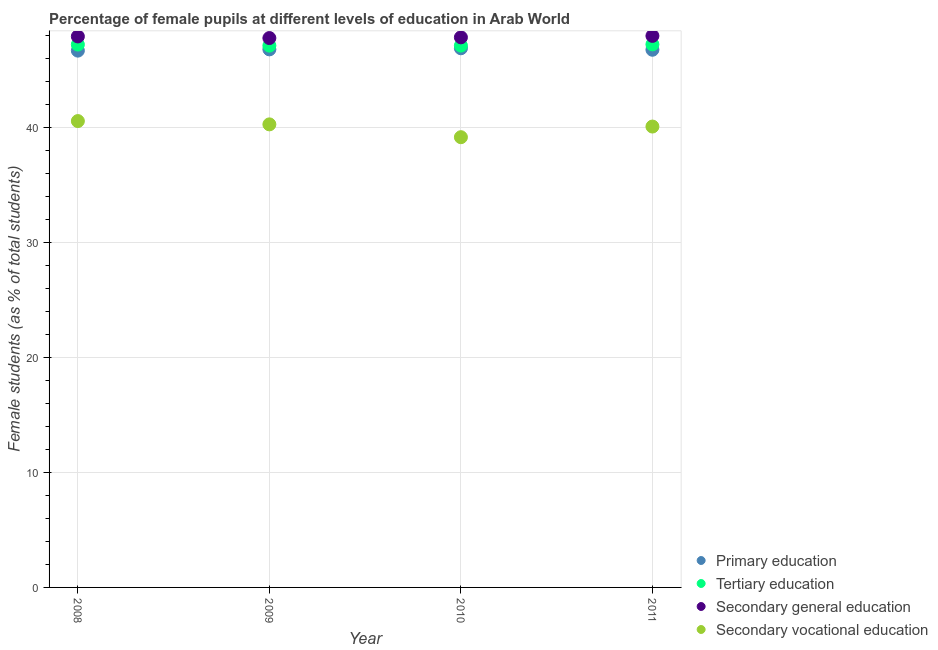What is the percentage of female students in primary education in 2008?
Offer a very short reply. 46.71. Across all years, what is the maximum percentage of female students in tertiary education?
Make the answer very short. 47.25. Across all years, what is the minimum percentage of female students in primary education?
Offer a very short reply. 46.71. What is the total percentage of female students in secondary vocational education in the graph?
Your answer should be compact. 160.15. What is the difference between the percentage of female students in secondary education in 2009 and that in 2010?
Ensure brevity in your answer.  -0.06. What is the difference between the percentage of female students in secondary education in 2011 and the percentage of female students in tertiary education in 2010?
Give a very brief answer. 0.84. What is the average percentage of female students in tertiary education per year?
Offer a very short reply. 47.19. In the year 2008, what is the difference between the percentage of female students in primary education and percentage of female students in secondary education?
Provide a short and direct response. -1.23. In how many years, is the percentage of female students in secondary education greater than 20 %?
Your answer should be compact. 4. What is the ratio of the percentage of female students in secondary education in 2009 to that in 2011?
Give a very brief answer. 1. Is the percentage of female students in primary education in 2009 less than that in 2010?
Provide a short and direct response. Yes. What is the difference between the highest and the second highest percentage of female students in primary education?
Give a very brief answer. 0.1. What is the difference between the highest and the lowest percentage of female students in primary education?
Give a very brief answer. 0.21. In how many years, is the percentage of female students in tertiary education greater than the average percentage of female students in tertiary education taken over all years?
Offer a terse response. 2. Is the sum of the percentage of female students in secondary education in 2010 and 2011 greater than the maximum percentage of female students in secondary vocational education across all years?
Your response must be concise. Yes. Is it the case that in every year, the sum of the percentage of female students in primary education and percentage of female students in tertiary education is greater than the percentage of female students in secondary education?
Provide a short and direct response. Yes. Does the percentage of female students in secondary education monotonically increase over the years?
Make the answer very short. No. Is the percentage of female students in tertiary education strictly greater than the percentage of female students in secondary vocational education over the years?
Make the answer very short. Yes. Is the percentage of female students in primary education strictly less than the percentage of female students in secondary vocational education over the years?
Ensure brevity in your answer.  No. How many dotlines are there?
Keep it short and to the point. 4. Are the values on the major ticks of Y-axis written in scientific E-notation?
Provide a succinct answer. No. Does the graph contain any zero values?
Ensure brevity in your answer.  No. How many legend labels are there?
Make the answer very short. 4. What is the title of the graph?
Provide a short and direct response. Percentage of female pupils at different levels of education in Arab World. What is the label or title of the X-axis?
Offer a very short reply. Year. What is the label or title of the Y-axis?
Ensure brevity in your answer.  Female students (as % of total students). What is the Female students (as % of total students) of Primary education in 2008?
Give a very brief answer. 46.71. What is the Female students (as % of total students) in Tertiary education in 2008?
Provide a short and direct response. 47.24. What is the Female students (as % of total students) of Secondary general education in 2008?
Ensure brevity in your answer.  47.94. What is the Female students (as % of total students) in Secondary vocational education in 2008?
Ensure brevity in your answer.  40.58. What is the Female students (as % of total students) of Primary education in 2009?
Offer a very short reply. 46.82. What is the Female students (as % of total students) in Tertiary education in 2009?
Offer a terse response. 47.14. What is the Female students (as % of total students) in Secondary general education in 2009?
Offer a terse response. 47.8. What is the Female students (as % of total students) in Secondary vocational education in 2009?
Your response must be concise. 40.29. What is the Female students (as % of total students) in Primary education in 2010?
Keep it short and to the point. 46.91. What is the Female students (as % of total students) of Tertiary education in 2010?
Provide a succinct answer. 47.15. What is the Female students (as % of total students) of Secondary general education in 2010?
Offer a terse response. 47.86. What is the Female students (as % of total students) of Secondary vocational education in 2010?
Keep it short and to the point. 39.18. What is the Female students (as % of total students) in Primary education in 2011?
Keep it short and to the point. 46.79. What is the Female students (as % of total students) of Tertiary education in 2011?
Your response must be concise. 47.25. What is the Female students (as % of total students) in Secondary general education in 2011?
Provide a short and direct response. 47.99. What is the Female students (as % of total students) in Secondary vocational education in 2011?
Give a very brief answer. 40.1. Across all years, what is the maximum Female students (as % of total students) of Primary education?
Make the answer very short. 46.91. Across all years, what is the maximum Female students (as % of total students) of Tertiary education?
Provide a succinct answer. 47.25. Across all years, what is the maximum Female students (as % of total students) in Secondary general education?
Provide a succinct answer. 47.99. Across all years, what is the maximum Female students (as % of total students) of Secondary vocational education?
Provide a short and direct response. 40.58. Across all years, what is the minimum Female students (as % of total students) of Primary education?
Make the answer very short. 46.71. Across all years, what is the minimum Female students (as % of total students) of Tertiary education?
Make the answer very short. 47.14. Across all years, what is the minimum Female students (as % of total students) in Secondary general education?
Your response must be concise. 47.8. Across all years, what is the minimum Female students (as % of total students) in Secondary vocational education?
Provide a succinct answer. 39.18. What is the total Female students (as % of total students) in Primary education in the graph?
Offer a terse response. 187.23. What is the total Female students (as % of total students) in Tertiary education in the graph?
Provide a succinct answer. 188.78. What is the total Female students (as % of total students) in Secondary general education in the graph?
Give a very brief answer. 191.6. What is the total Female students (as % of total students) in Secondary vocational education in the graph?
Provide a succinct answer. 160.15. What is the difference between the Female students (as % of total students) of Primary education in 2008 and that in 2009?
Ensure brevity in your answer.  -0.11. What is the difference between the Female students (as % of total students) of Tertiary education in 2008 and that in 2009?
Offer a terse response. 0.09. What is the difference between the Female students (as % of total students) in Secondary general education in 2008 and that in 2009?
Your answer should be very brief. 0.14. What is the difference between the Female students (as % of total students) of Secondary vocational education in 2008 and that in 2009?
Ensure brevity in your answer.  0.29. What is the difference between the Female students (as % of total students) in Primary education in 2008 and that in 2010?
Your response must be concise. -0.21. What is the difference between the Female students (as % of total students) in Tertiary education in 2008 and that in 2010?
Offer a terse response. 0.09. What is the difference between the Female students (as % of total students) in Secondary general education in 2008 and that in 2010?
Keep it short and to the point. 0.08. What is the difference between the Female students (as % of total students) of Secondary vocational education in 2008 and that in 2010?
Provide a short and direct response. 1.4. What is the difference between the Female students (as % of total students) of Primary education in 2008 and that in 2011?
Keep it short and to the point. -0.08. What is the difference between the Female students (as % of total students) in Tertiary education in 2008 and that in 2011?
Your response must be concise. -0.02. What is the difference between the Female students (as % of total students) of Secondary general education in 2008 and that in 2011?
Ensure brevity in your answer.  -0.05. What is the difference between the Female students (as % of total students) of Secondary vocational education in 2008 and that in 2011?
Your response must be concise. 0.48. What is the difference between the Female students (as % of total students) of Primary education in 2009 and that in 2010?
Keep it short and to the point. -0.1. What is the difference between the Female students (as % of total students) of Tertiary education in 2009 and that in 2010?
Your answer should be very brief. -0. What is the difference between the Female students (as % of total students) in Secondary general education in 2009 and that in 2010?
Your answer should be very brief. -0.06. What is the difference between the Female students (as % of total students) of Secondary vocational education in 2009 and that in 2010?
Your answer should be very brief. 1.12. What is the difference between the Female students (as % of total students) of Primary education in 2009 and that in 2011?
Your answer should be compact. 0.03. What is the difference between the Female students (as % of total students) in Tertiary education in 2009 and that in 2011?
Ensure brevity in your answer.  -0.11. What is the difference between the Female students (as % of total students) of Secondary general education in 2009 and that in 2011?
Offer a very short reply. -0.19. What is the difference between the Female students (as % of total students) in Secondary vocational education in 2009 and that in 2011?
Your answer should be compact. 0.19. What is the difference between the Female students (as % of total students) in Primary education in 2010 and that in 2011?
Provide a succinct answer. 0.13. What is the difference between the Female students (as % of total students) in Tertiary education in 2010 and that in 2011?
Provide a succinct answer. -0.11. What is the difference between the Female students (as % of total students) of Secondary general education in 2010 and that in 2011?
Keep it short and to the point. -0.13. What is the difference between the Female students (as % of total students) of Secondary vocational education in 2010 and that in 2011?
Give a very brief answer. -0.93. What is the difference between the Female students (as % of total students) in Primary education in 2008 and the Female students (as % of total students) in Tertiary education in 2009?
Ensure brevity in your answer.  -0.43. What is the difference between the Female students (as % of total students) of Primary education in 2008 and the Female students (as % of total students) of Secondary general education in 2009?
Give a very brief answer. -1.09. What is the difference between the Female students (as % of total students) in Primary education in 2008 and the Female students (as % of total students) in Secondary vocational education in 2009?
Your answer should be compact. 6.42. What is the difference between the Female students (as % of total students) in Tertiary education in 2008 and the Female students (as % of total students) in Secondary general education in 2009?
Offer a terse response. -0.57. What is the difference between the Female students (as % of total students) in Tertiary education in 2008 and the Female students (as % of total students) in Secondary vocational education in 2009?
Your answer should be very brief. 6.94. What is the difference between the Female students (as % of total students) of Secondary general education in 2008 and the Female students (as % of total students) of Secondary vocational education in 2009?
Offer a terse response. 7.65. What is the difference between the Female students (as % of total students) of Primary education in 2008 and the Female students (as % of total students) of Tertiary education in 2010?
Provide a succinct answer. -0.44. What is the difference between the Female students (as % of total students) of Primary education in 2008 and the Female students (as % of total students) of Secondary general education in 2010?
Make the answer very short. -1.16. What is the difference between the Female students (as % of total students) in Primary education in 2008 and the Female students (as % of total students) in Secondary vocational education in 2010?
Offer a very short reply. 7.53. What is the difference between the Female students (as % of total students) of Tertiary education in 2008 and the Female students (as % of total students) of Secondary general education in 2010?
Offer a very short reply. -0.63. What is the difference between the Female students (as % of total students) in Tertiary education in 2008 and the Female students (as % of total students) in Secondary vocational education in 2010?
Your answer should be compact. 8.06. What is the difference between the Female students (as % of total students) of Secondary general education in 2008 and the Female students (as % of total students) of Secondary vocational education in 2010?
Ensure brevity in your answer.  8.77. What is the difference between the Female students (as % of total students) in Primary education in 2008 and the Female students (as % of total students) in Tertiary education in 2011?
Provide a short and direct response. -0.54. What is the difference between the Female students (as % of total students) in Primary education in 2008 and the Female students (as % of total students) in Secondary general education in 2011?
Make the answer very short. -1.28. What is the difference between the Female students (as % of total students) of Primary education in 2008 and the Female students (as % of total students) of Secondary vocational education in 2011?
Provide a short and direct response. 6.61. What is the difference between the Female students (as % of total students) in Tertiary education in 2008 and the Female students (as % of total students) in Secondary general education in 2011?
Give a very brief answer. -0.75. What is the difference between the Female students (as % of total students) in Tertiary education in 2008 and the Female students (as % of total students) in Secondary vocational education in 2011?
Offer a terse response. 7.13. What is the difference between the Female students (as % of total students) of Secondary general education in 2008 and the Female students (as % of total students) of Secondary vocational education in 2011?
Your response must be concise. 7.84. What is the difference between the Female students (as % of total students) in Primary education in 2009 and the Female students (as % of total students) in Tertiary education in 2010?
Provide a short and direct response. -0.33. What is the difference between the Female students (as % of total students) in Primary education in 2009 and the Female students (as % of total students) in Secondary general education in 2010?
Ensure brevity in your answer.  -1.05. What is the difference between the Female students (as % of total students) in Primary education in 2009 and the Female students (as % of total students) in Secondary vocational education in 2010?
Offer a very short reply. 7.64. What is the difference between the Female students (as % of total students) in Tertiary education in 2009 and the Female students (as % of total students) in Secondary general education in 2010?
Ensure brevity in your answer.  -0.72. What is the difference between the Female students (as % of total students) of Tertiary education in 2009 and the Female students (as % of total students) of Secondary vocational education in 2010?
Provide a succinct answer. 7.97. What is the difference between the Female students (as % of total students) of Secondary general education in 2009 and the Female students (as % of total students) of Secondary vocational education in 2010?
Provide a short and direct response. 8.63. What is the difference between the Female students (as % of total students) in Primary education in 2009 and the Female students (as % of total students) in Tertiary education in 2011?
Give a very brief answer. -0.43. What is the difference between the Female students (as % of total students) of Primary education in 2009 and the Female students (as % of total students) of Secondary general education in 2011?
Offer a terse response. -1.17. What is the difference between the Female students (as % of total students) in Primary education in 2009 and the Female students (as % of total students) in Secondary vocational education in 2011?
Offer a terse response. 6.72. What is the difference between the Female students (as % of total students) of Tertiary education in 2009 and the Female students (as % of total students) of Secondary general education in 2011?
Provide a succinct answer. -0.85. What is the difference between the Female students (as % of total students) in Tertiary education in 2009 and the Female students (as % of total students) in Secondary vocational education in 2011?
Your answer should be compact. 7.04. What is the difference between the Female students (as % of total students) in Secondary general education in 2009 and the Female students (as % of total students) in Secondary vocational education in 2011?
Provide a succinct answer. 7.7. What is the difference between the Female students (as % of total students) in Primary education in 2010 and the Female students (as % of total students) in Tertiary education in 2011?
Make the answer very short. -0.34. What is the difference between the Female students (as % of total students) in Primary education in 2010 and the Female students (as % of total students) in Secondary general education in 2011?
Your answer should be compact. -1.08. What is the difference between the Female students (as % of total students) of Primary education in 2010 and the Female students (as % of total students) of Secondary vocational education in 2011?
Your response must be concise. 6.81. What is the difference between the Female students (as % of total students) of Tertiary education in 2010 and the Female students (as % of total students) of Secondary general education in 2011?
Your answer should be very brief. -0.84. What is the difference between the Female students (as % of total students) of Tertiary education in 2010 and the Female students (as % of total students) of Secondary vocational education in 2011?
Provide a succinct answer. 7.04. What is the difference between the Female students (as % of total students) of Secondary general education in 2010 and the Female students (as % of total students) of Secondary vocational education in 2011?
Your answer should be very brief. 7.76. What is the average Female students (as % of total students) in Primary education per year?
Offer a very short reply. 46.81. What is the average Female students (as % of total students) in Tertiary education per year?
Make the answer very short. 47.2. What is the average Female students (as % of total students) in Secondary general education per year?
Your answer should be very brief. 47.9. What is the average Female students (as % of total students) of Secondary vocational education per year?
Your answer should be very brief. 40.04. In the year 2008, what is the difference between the Female students (as % of total students) of Primary education and Female students (as % of total students) of Tertiary education?
Make the answer very short. -0.53. In the year 2008, what is the difference between the Female students (as % of total students) in Primary education and Female students (as % of total students) in Secondary general education?
Your response must be concise. -1.23. In the year 2008, what is the difference between the Female students (as % of total students) in Primary education and Female students (as % of total students) in Secondary vocational education?
Your response must be concise. 6.13. In the year 2008, what is the difference between the Female students (as % of total students) of Tertiary education and Female students (as % of total students) of Secondary general education?
Offer a terse response. -0.71. In the year 2008, what is the difference between the Female students (as % of total students) of Tertiary education and Female students (as % of total students) of Secondary vocational education?
Offer a terse response. 6.66. In the year 2008, what is the difference between the Female students (as % of total students) of Secondary general education and Female students (as % of total students) of Secondary vocational education?
Keep it short and to the point. 7.36. In the year 2009, what is the difference between the Female students (as % of total students) of Primary education and Female students (as % of total students) of Tertiary education?
Make the answer very short. -0.33. In the year 2009, what is the difference between the Female students (as % of total students) in Primary education and Female students (as % of total students) in Secondary general education?
Keep it short and to the point. -0.98. In the year 2009, what is the difference between the Female students (as % of total students) in Primary education and Female students (as % of total students) in Secondary vocational education?
Your response must be concise. 6.53. In the year 2009, what is the difference between the Female students (as % of total students) in Tertiary education and Female students (as % of total students) in Secondary general education?
Your answer should be compact. -0.66. In the year 2009, what is the difference between the Female students (as % of total students) in Tertiary education and Female students (as % of total students) in Secondary vocational education?
Make the answer very short. 6.85. In the year 2009, what is the difference between the Female students (as % of total students) of Secondary general education and Female students (as % of total students) of Secondary vocational education?
Provide a succinct answer. 7.51. In the year 2010, what is the difference between the Female students (as % of total students) in Primary education and Female students (as % of total students) in Tertiary education?
Offer a terse response. -0.23. In the year 2010, what is the difference between the Female students (as % of total students) of Primary education and Female students (as % of total students) of Secondary general education?
Give a very brief answer. -0.95. In the year 2010, what is the difference between the Female students (as % of total students) of Primary education and Female students (as % of total students) of Secondary vocational education?
Give a very brief answer. 7.74. In the year 2010, what is the difference between the Female students (as % of total students) of Tertiary education and Female students (as % of total students) of Secondary general education?
Your answer should be compact. -0.72. In the year 2010, what is the difference between the Female students (as % of total students) in Tertiary education and Female students (as % of total students) in Secondary vocational education?
Your response must be concise. 7.97. In the year 2010, what is the difference between the Female students (as % of total students) of Secondary general education and Female students (as % of total students) of Secondary vocational education?
Your answer should be compact. 8.69. In the year 2011, what is the difference between the Female students (as % of total students) in Primary education and Female students (as % of total students) in Tertiary education?
Offer a very short reply. -0.47. In the year 2011, what is the difference between the Female students (as % of total students) in Primary education and Female students (as % of total students) in Secondary general education?
Make the answer very short. -1.21. In the year 2011, what is the difference between the Female students (as % of total students) of Primary education and Female students (as % of total students) of Secondary vocational education?
Provide a short and direct response. 6.68. In the year 2011, what is the difference between the Female students (as % of total students) of Tertiary education and Female students (as % of total students) of Secondary general education?
Give a very brief answer. -0.74. In the year 2011, what is the difference between the Female students (as % of total students) in Tertiary education and Female students (as % of total students) in Secondary vocational education?
Offer a terse response. 7.15. In the year 2011, what is the difference between the Female students (as % of total students) of Secondary general education and Female students (as % of total students) of Secondary vocational education?
Give a very brief answer. 7.89. What is the ratio of the Female students (as % of total students) in Tertiary education in 2008 to that in 2009?
Provide a short and direct response. 1. What is the ratio of the Female students (as % of total students) of Secondary vocational education in 2008 to that in 2009?
Give a very brief answer. 1.01. What is the ratio of the Female students (as % of total students) of Secondary general education in 2008 to that in 2010?
Your answer should be very brief. 1. What is the ratio of the Female students (as % of total students) in Secondary vocational education in 2008 to that in 2010?
Offer a terse response. 1.04. What is the ratio of the Female students (as % of total students) in Primary education in 2008 to that in 2011?
Provide a short and direct response. 1. What is the ratio of the Female students (as % of total students) in Tertiary education in 2008 to that in 2011?
Your answer should be compact. 1. What is the ratio of the Female students (as % of total students) of Secondary general education in 2008 to that in 2011?
Offer a terse response. 1. What is the ratio of the Female students (as % of total students) of Secondary vocational education in 2008 to that in 2011?
Provide a short and direct response. 1.01. What is the ratio of the Female students (as % of total students) of Primary education in 2009 to that in 2010?
Your answer should be very brief. 1. What is the ratio of the Female students (as % of total students) in Tertiary education in 2009 to that in 2010?
Give a very brief answer. 1. What is the ratio of the Female students (as % of total students) in Secondary vocational education in 2009 to that in 2010?
Your response must be concise. 1.03. What is the ratio of the Female students (as % of total students) in Primary education in 2009 to that in 2011?
Offer a terse response. 1. What is the ratio of the Female students (as % of total students) of Secondary general education in 2009 to that in 2011?
Ensure brevity in your answer.  1. What is the ratio of the Female students (as % of total students) in Secondary vocational education in 2010 to that in 2011?
Make the answer very short. 0.98. What is the difference between the highest and the second highest Female students (as % of total students) of Primary education?
Offer a very short reply. 0.1. What is the difference between the highest and the second highest Female students (as % of total students) of Tertiary education?
Provide a short and direct response. 0.02. What is the difference between the highest and the second highest Female students (as % of total students) of Secondary general education?
Offer a very short reply. 0.05. What is the difference between the highest and the second highest Female students (as % of total students) of Secondary vocational education?
Give a very brief answer. 0.29. What is the difference between the highest and the lowest Female students (as % of total students) of Primary education?
Your answer should be compact. 0.21. What is the difference between the highest and the lowest Female students (as % of total students) of Tertiary education?
Offer a very short reply. 0.11. What is the difference between the highest and the lowest Female students (as % of total students) in Secondary general education?
Ensure brevity in your answer.  0.19. What is the difference between the highest and the lowest Female students (as % of total students) of Secondary vocational education?
Offer a terse response. 1.4. 